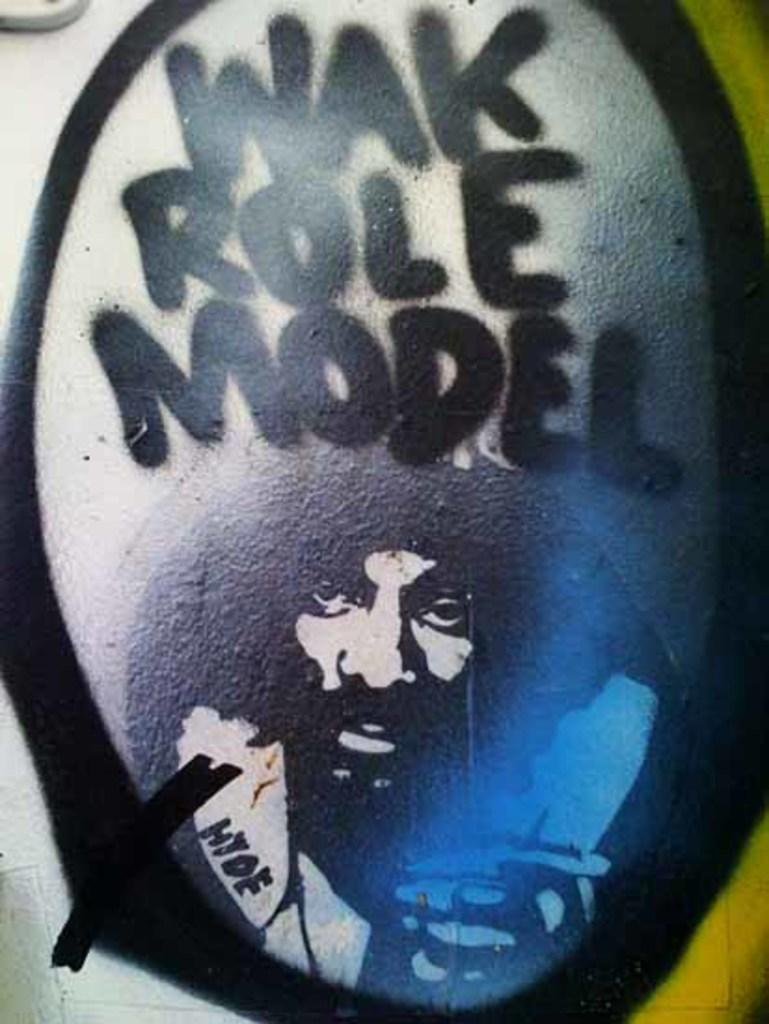What is the main subject of the image? The main subject of the image is a person's face. Where is the person's face located in the image? The person's face is at the bottom of the image. What else can be seen in the image besides the person's face? There is some text in the image. Where is the text located in the image? The text is at the top of the image. What type of bird can be seen flying in the image? There is no bird present in the image; it only features a person's face and some text. What design is featured on the flag in the image? There is no flag present in the image. 